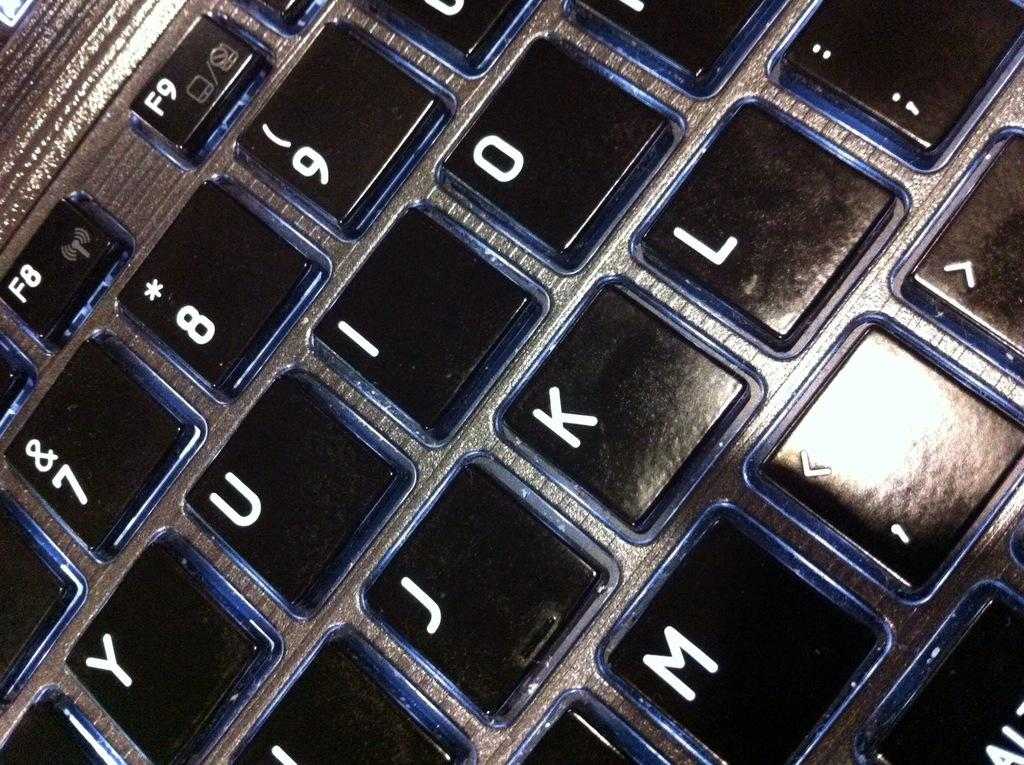<image>
Write a terse but informative summary of the picture. a keyboard with many different numbers on it 